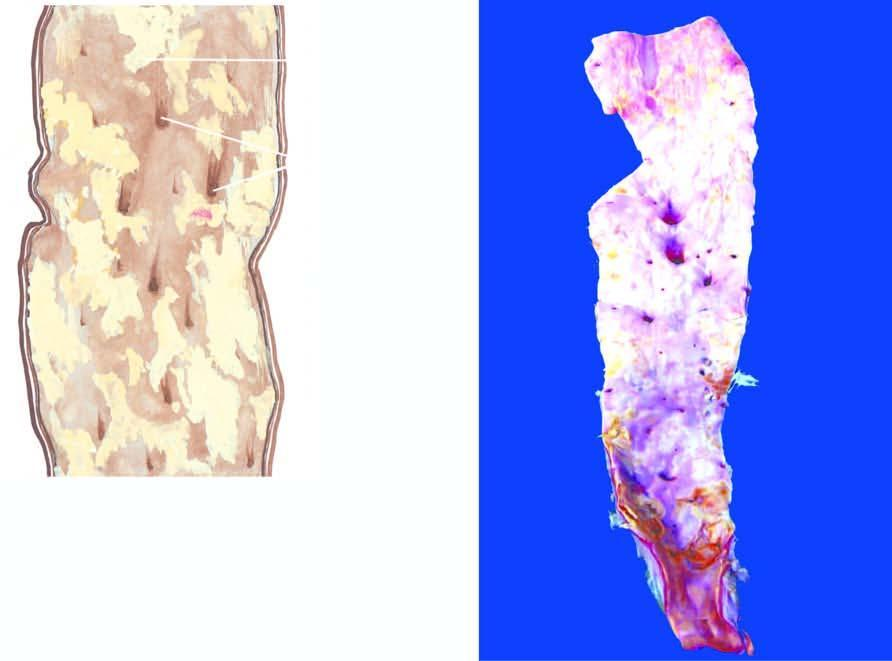how many have ulcerated surface?
Answer the question using a single word or phrase. A few 